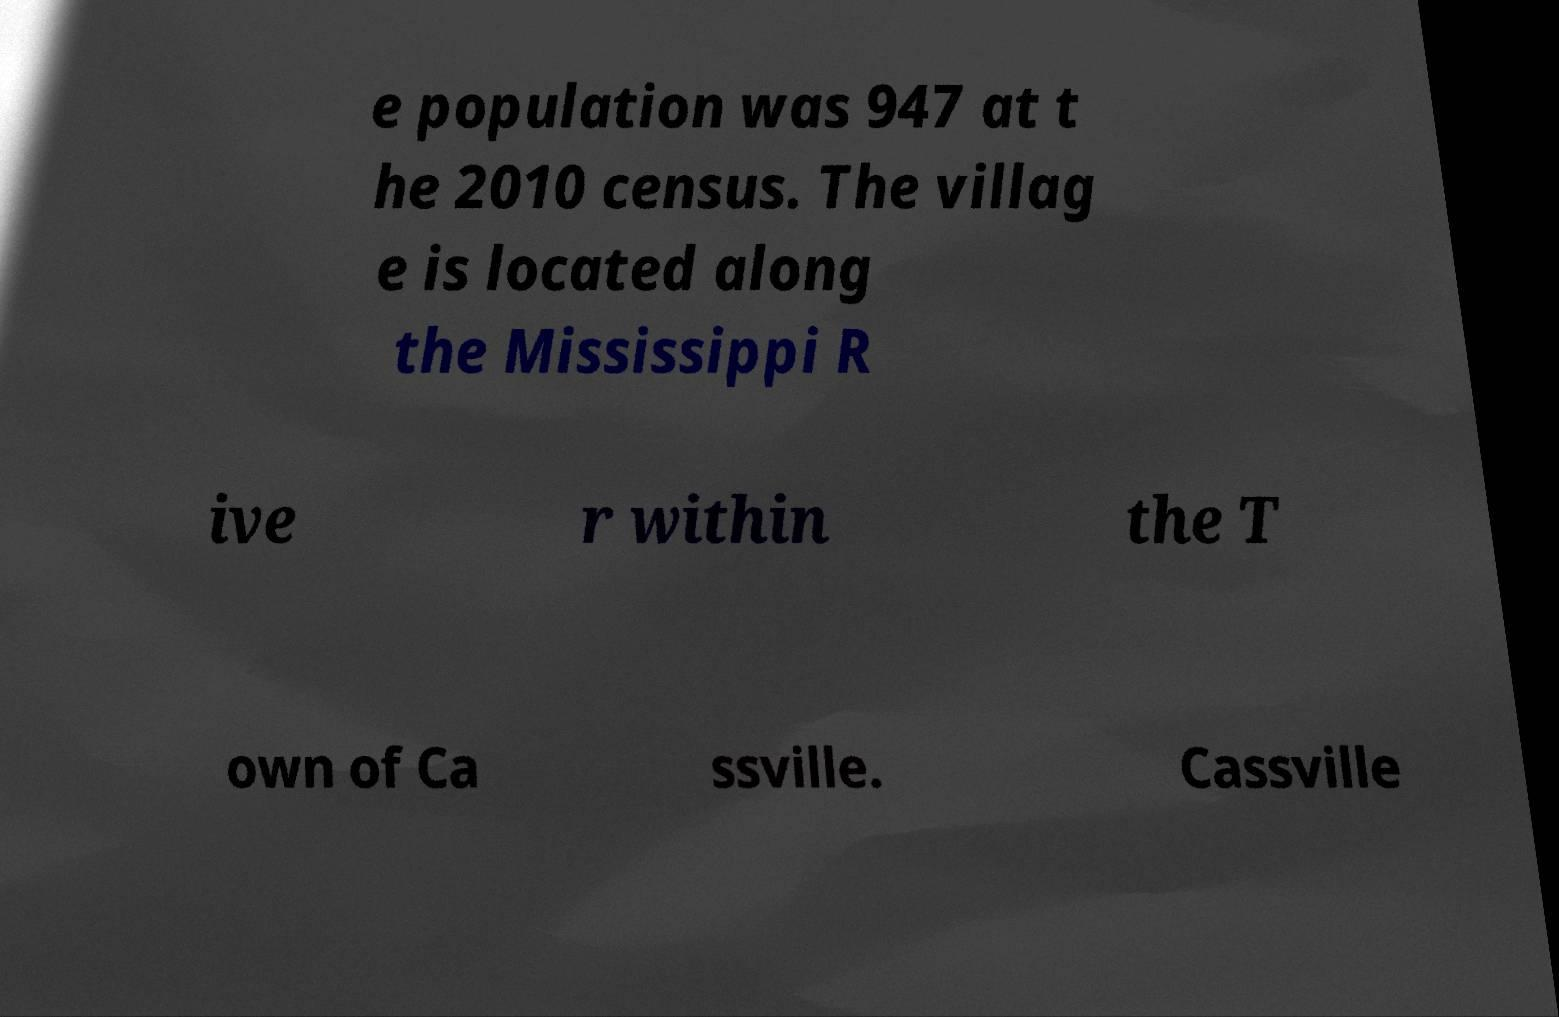There's text embedded in this image that I need extracted. Can you transcribe it verbatim? e population was 947 at t he 2010 census. The villag e is located along the Mississippi R ive r within the T own of Ca ssville. Cassville 